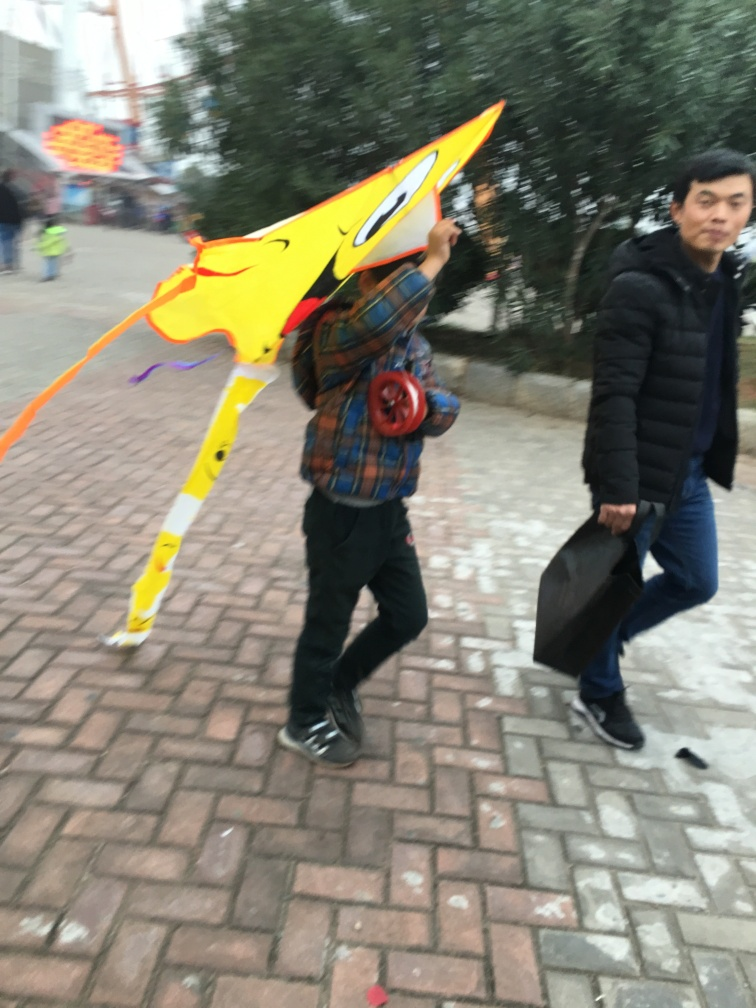What time of day does it seem to be in the picture? Taking into account the lighting and the long shadows present, it suggests that the photo was taken either in the early morning or late afternoon, during what photographers would refer to as 'golden hour,' which lends a warm ambiance to the scene. Based on this time of day, what might the weather be like? Given the lighting and the attire of the people in the image, it seems to be a cool day. The individual is wearing a jacket, indicating it might be brisk, and the willingness to be outside with a kite suggests it's not raining or too uncomfortable. 